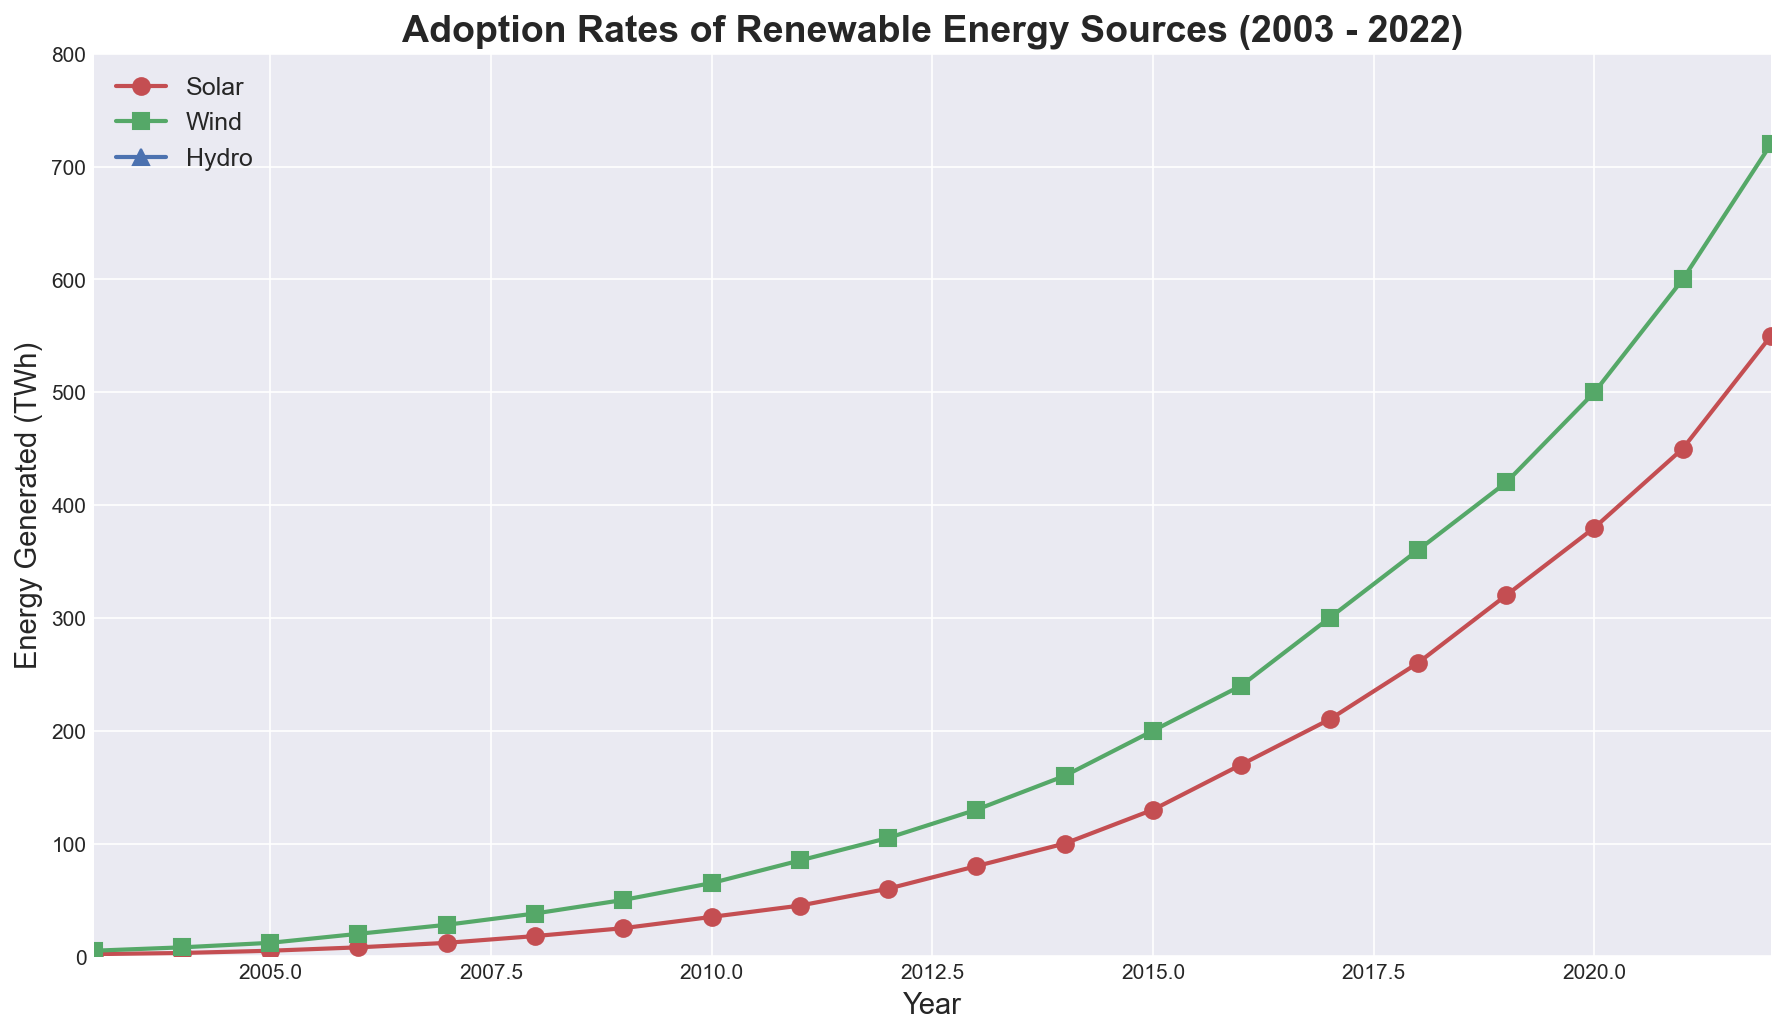What type of renewable energy source showed the highest growth rate from 2003 to 2022? To find out which renewable energy source showed the highest growth rate, we need to compare the increase in TWh between 2003 and 2022 for each type (Solar, Wind, Hydro). Solar increased from 2 TWh to 550 TWh, Wind increased from 5 TWh to 720 TWh, and Hydro increased from 3000 TWh to 3950 TWh. The highest growth rate is observed in Solar.
Answer: Solar Between which two consecutive years did Solar energy have the highest increase in TWh? To determine this, examine the year-over-year differences in Solar TWh. The largest increase appears between 2021 (450 TWh) and 2022 (550 TWh), which is a difference of 100 TWh.
Answer: 2021 and 2022 How does the total energy generated by Solar and Wind in 2022 compare to the energy generated by Hydro in 2022? In 2022, Solar generated 550 TWh and Wind generated 720 TWh, giving a total of 550 + 720 = 1270 TWh. Hydro generated 3950 TWh. Therefore, Hydro's energy generation in 2022 is significantly higher.
Answer: Hydro is significantly higher Which renewable energy source consistently generates the least amount of TWh throughout the 20-year period? By examining the graphs, it is evident that Solar and Wind started with much lower values compared to Hydro, with Solar always having the smallest TWh values each year.
Answer: Solar What is the difference in TWh between Wind and Solar energy in 2022? In 2022, Wind generated 720 TWh, while Solar generated 550 TWh. The difference is 720 - 550 = 170 TWh.
Answer: 170 TWh What years did Wind energy surpass 100 TWh and 500 TWh? To find these years, look at the Wind TWh data: Wind surpassed 100 TWh in 2012 and 500 TWh in 2020.
Answer: 2012 and 2020 How much more TWh did Hydro generate compared to Wind in 2003? In 2003, Hydro generated 3000 TWh and Wind generated 5 TWh. The difference is 3000 - 5 = 2995 TWh.
Answer: 2995 TWh 